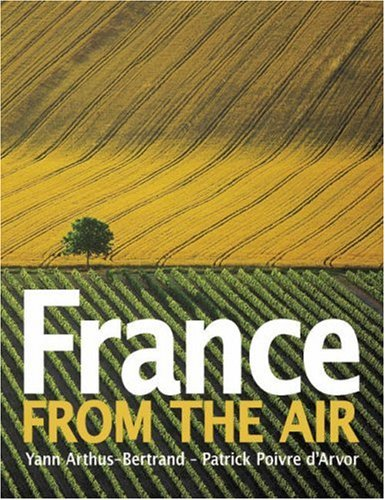How does this book contribute to appreciating cultural landscapes? By offering an aerial perspective, this book allows viewers to appreciate the intricacy and cultural significance of land use in France, highlighting how historical and geographical elements shape the visual landscape. 